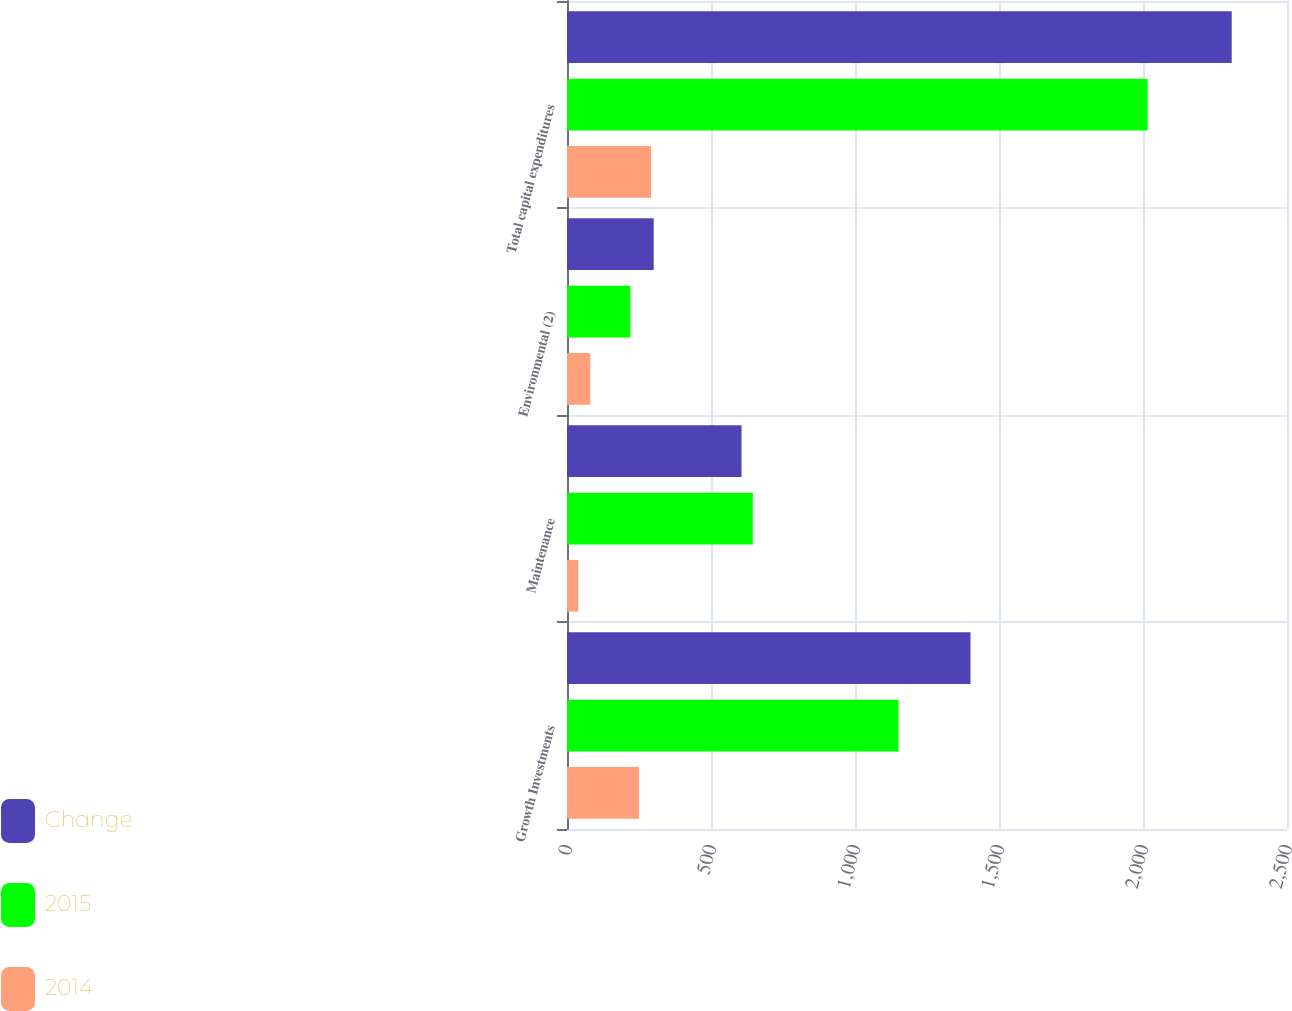Convert chart. <chart><loc_0><loc_0><loc_500><loc_500><stacked_bar_chart><ecel><fcel>Growth Investments<fcel>Maintenance<fcel>Environmental (2)<fcel>Total capital expenditures<nl><fcel>Change<fcel>1401<fcel>606<fcel>301<fcel>2308<nl><fcel>2015<fcel>1151<fcel>645<fcel>220<fcel>2016<nl><fcel>2014<fcel>250<fcel>39<fcel>81<fcel>292<nl></chart> 